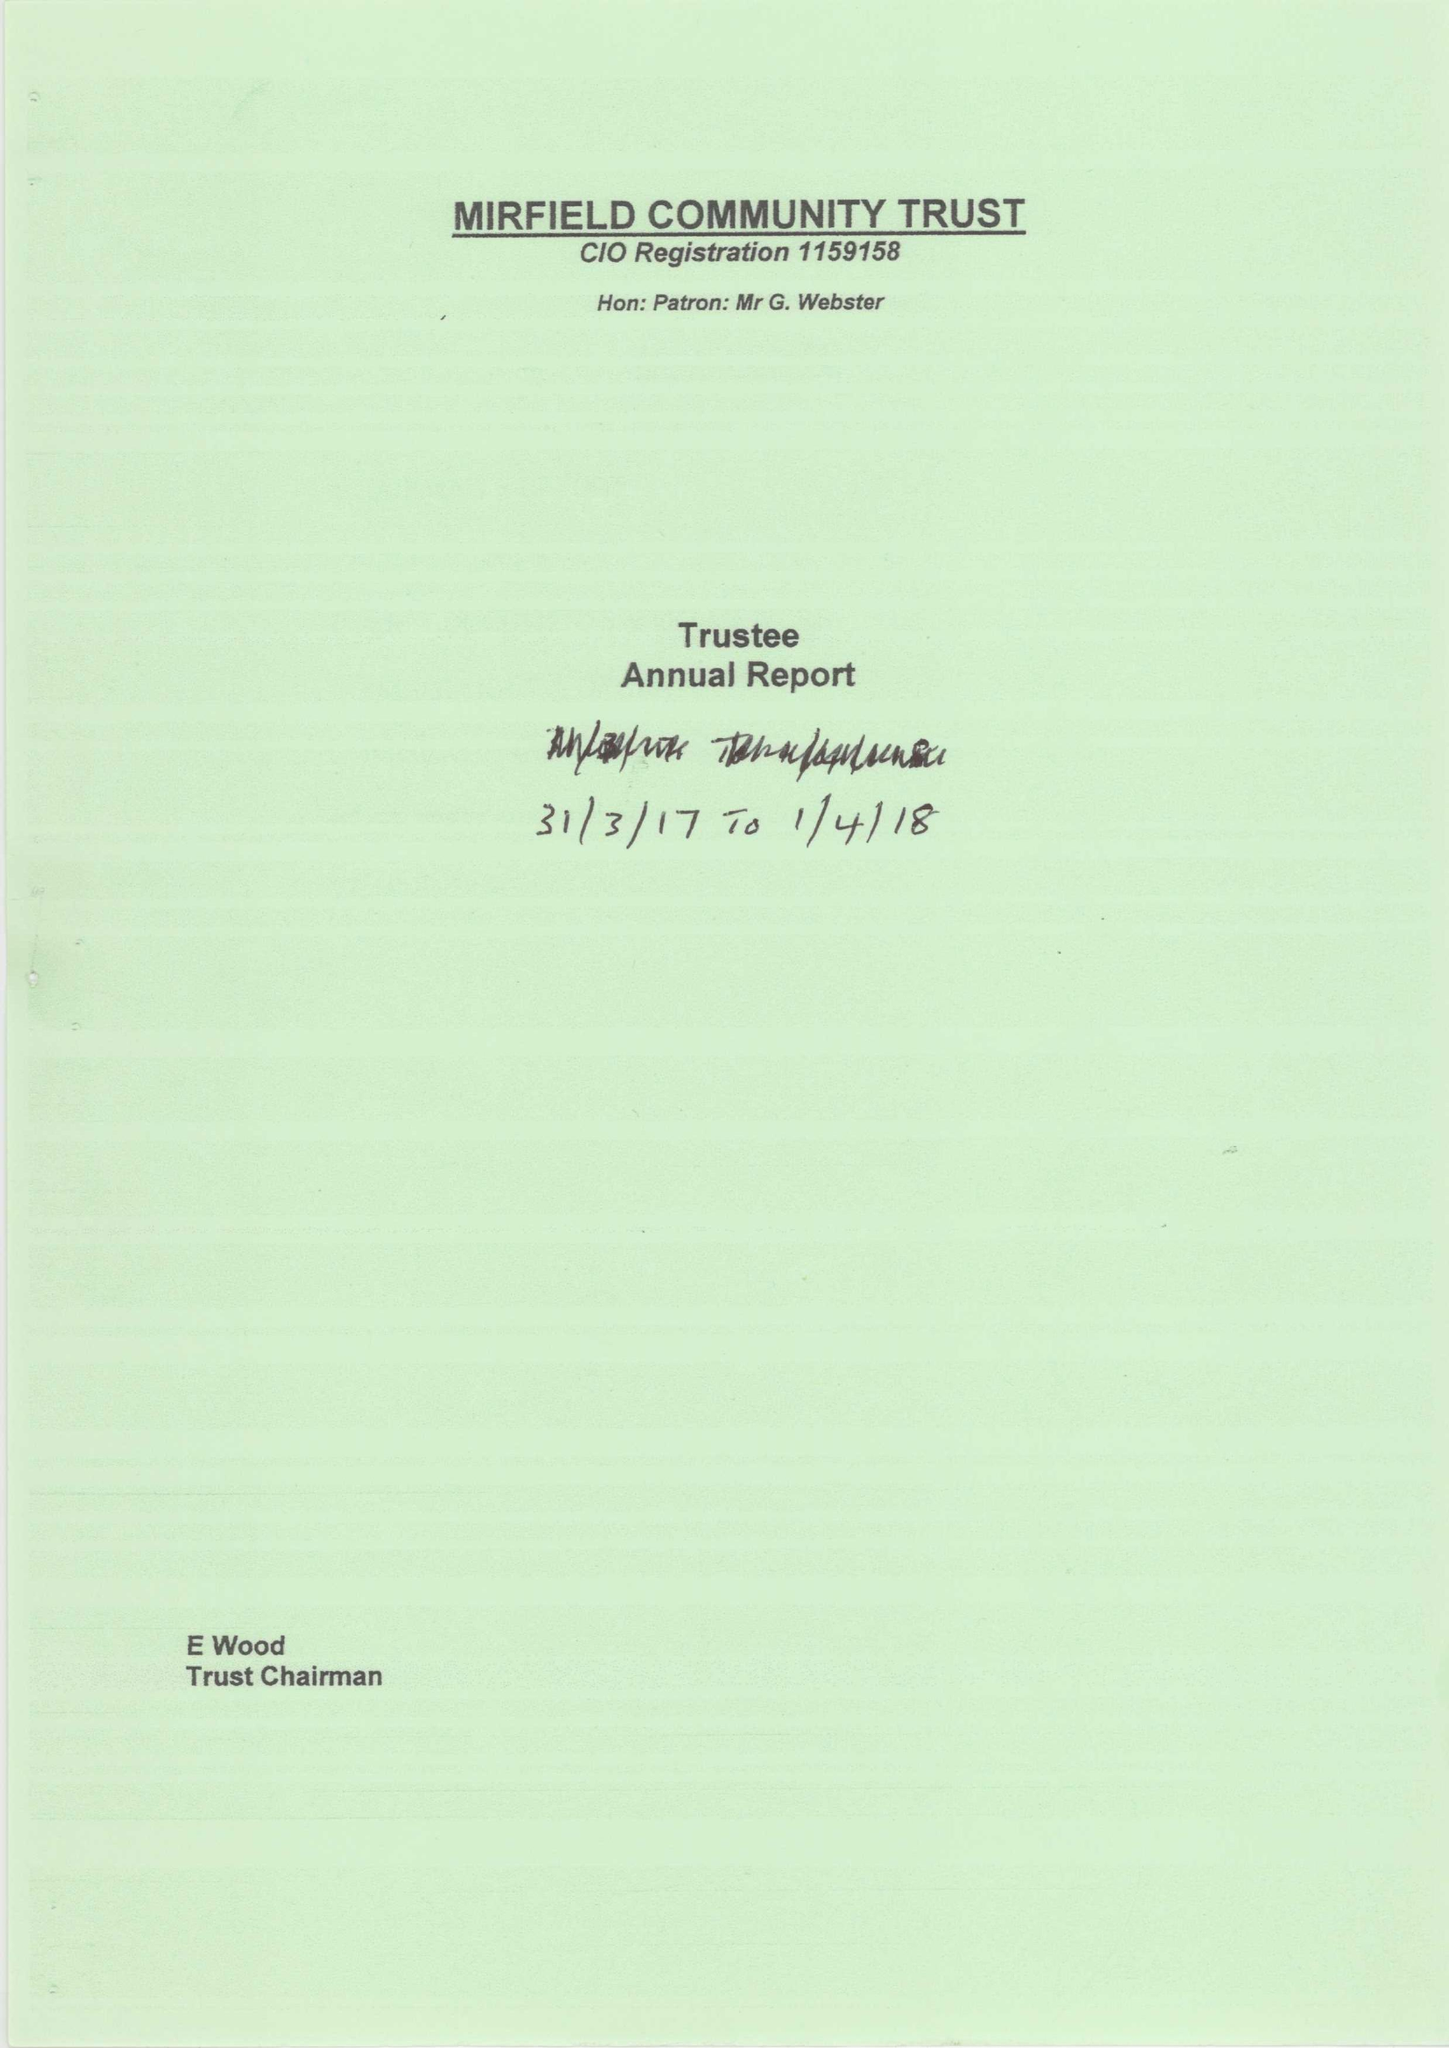What is the value for the report_date?
Answer the question using a single word or phrase. 2018-03-31 